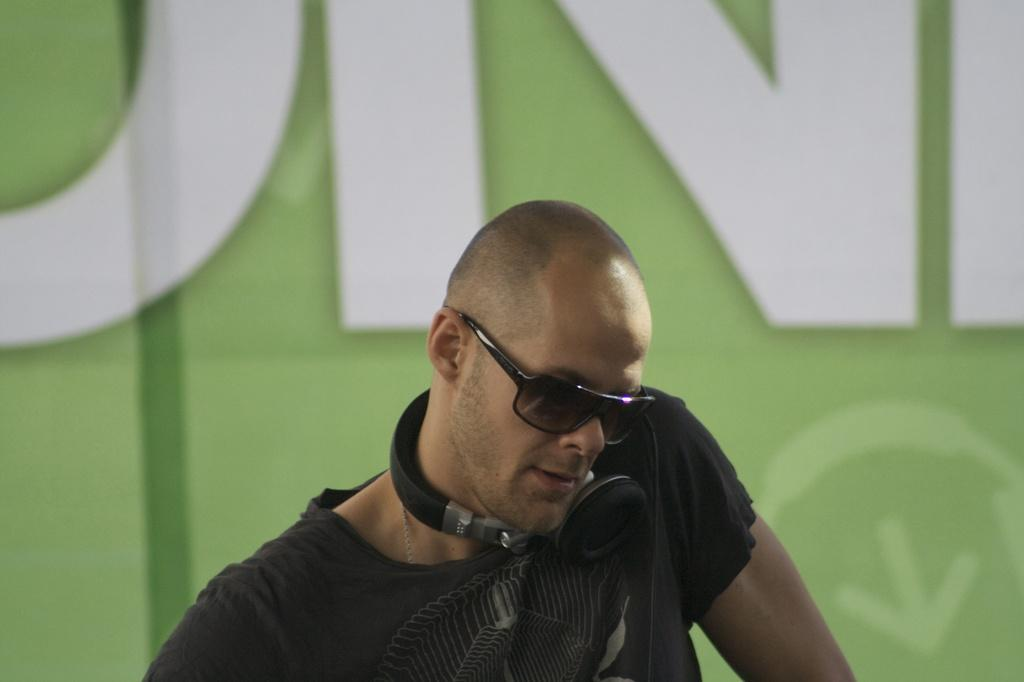Who is the main subject in the image? There is a man in the middle of the image. What is the man wearing on his ears? The man is wearing headphones. What type of eyewear is the man wearing? The man is wearing spectacles. What can be seen in the background of the image? There is a hoarding in the background of the image. What type of berry is the man holding in the image? There is no berry present in the image; the man is wearing headphones and spectacles. How is the man using the hook in the image? There is no hook present in the image; the man is wearing headphones and spectacles. 